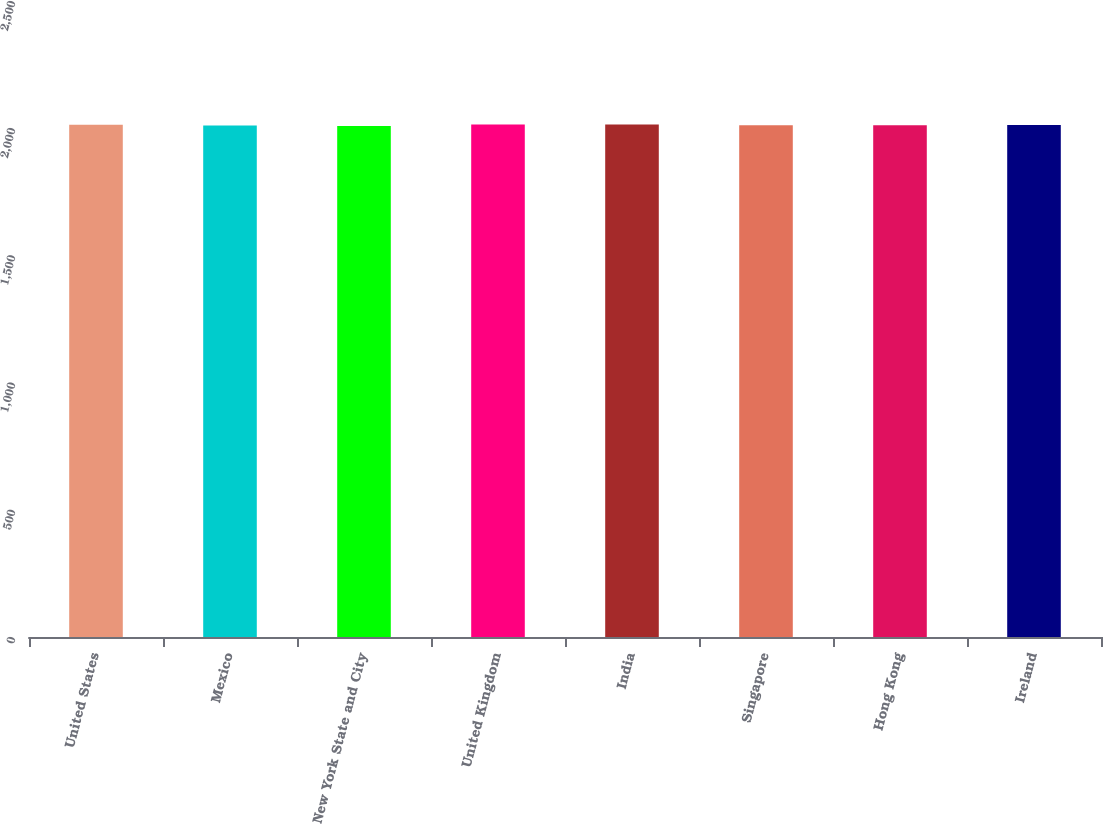<chart> <loc_0><loc_0><loc_500><loc_500><bar_chart><fcel>United States<fcel>Mexico<fcel>New York State and City<fcel>United Kingdom<fcel>India<fcel>Singapore<fcel>Hong Kong<fcel>Ireland<nl><fcel>2014<fcel>2011<fcel>2009<fcel>2014.5<fcel>2015<fcel>2011.5<fcel>2012<fcel>2013<nl></chart> 